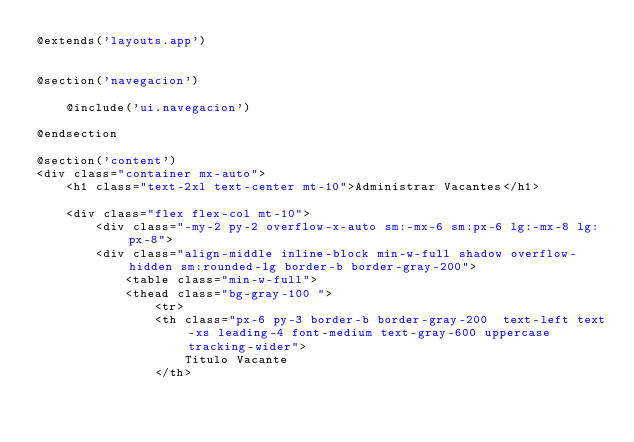<code> <loc_0><loc_0><loc_500><loc_500><_PHP_>@extends('layouts.app')


@section('navegacion')
    
    @include('ui.navegacion')

@endsection

@section('content')
<div class="container mx-auto">
    <h1 class="text-2xl text-center mt-10">Administrar Vacantes</h1>

    <div class="flex flex-col mt-10">
        <div class="-my-2 py-2 overflow-x-auto sm:-mx-6 sm:px-6 lg:-mx-8 lg:px-8">
        <div class="align-middle inline-block min-w-full shadow overflow-hidden sm:rounded-lg border-b border-gray-200">
            <table class="min-w-full">
            <thead class="bg-gray-100 ">
                <tr>
                <th class="px-6 py-3 border-b border-gray-200  text-left text-xs leading-4 font-medium text-gray-600 uppercase tracking-wider">
                    Titulo Vacante
                </th></code> 